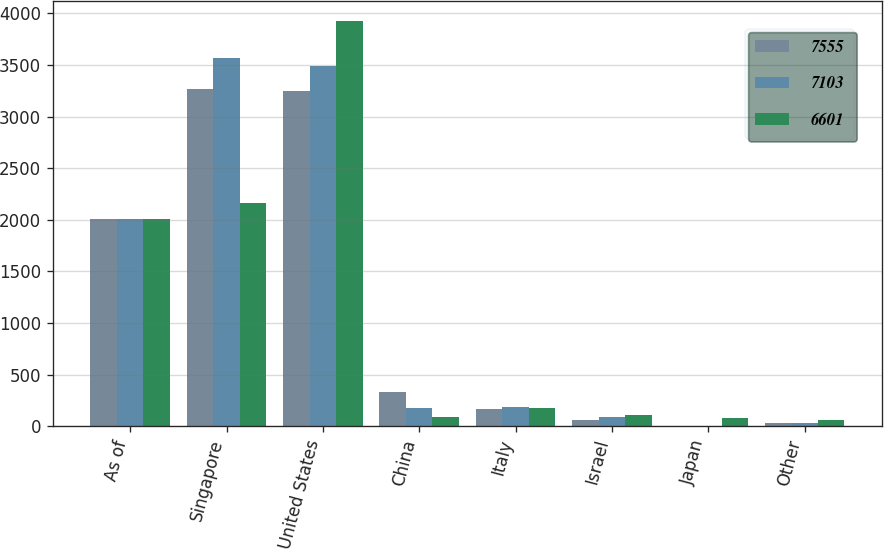Convert chart to OTSL. <chart><loc_0><loc_0><loc_500><loc_500><stacked_bar_chart><ecel><fcel>As of<fcel>Singapore<fcel>United States<fcel>China<fcel>Italy<fcel>Israel<fcel>Japan<fcel>Other<nl><fcel>7555<fcel>2012<fcel>3270<fcel>3246<fcel>328<fcel>163<fcel>59<fcel>2<fcel>35<nl><fcel>7103<fcel>2011<fcel>3569<fcel>3487<fcel>179<fcel>190<fcel>94<fcel>1<fcel>35<nl><fcel>6601<fcel>2010<fcel>2161<fcel>3925<fcel>90<fcel>173<fcel>111<fcel>81<fcel>60<nl></chart> 